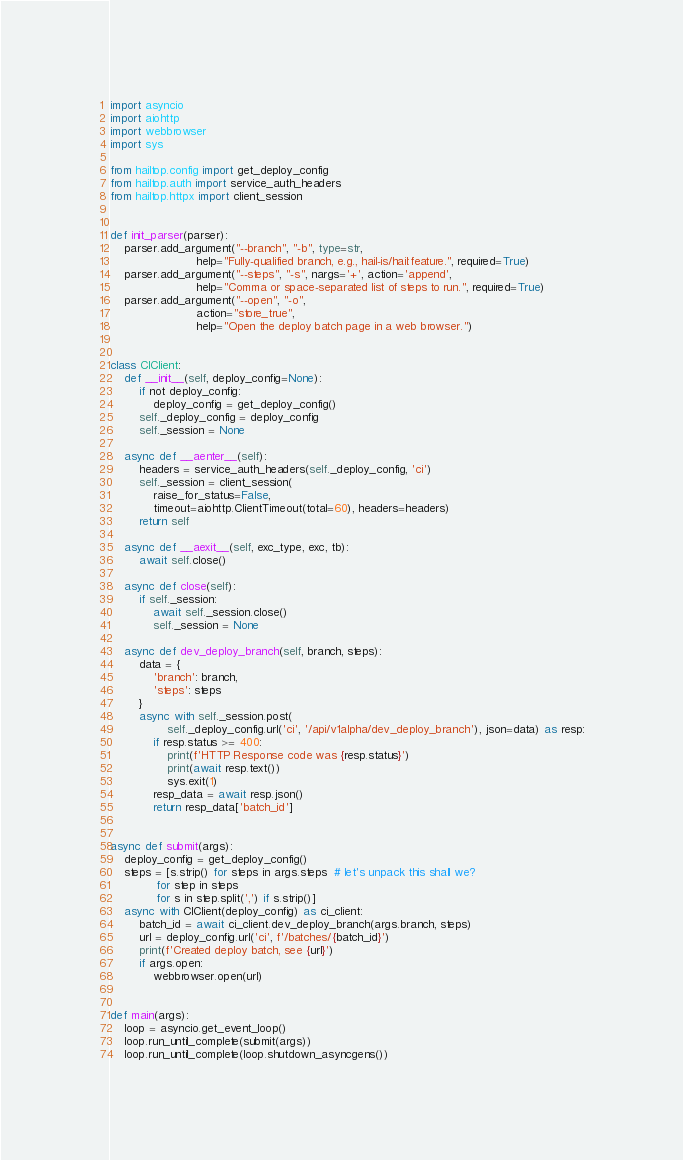<code> <loc_0><loc_0><loc_500><loc_500><_Python_>import asyncio
import aiohttp
import webbrowser
import sys

from hailtop.config import get_deploy_config
from hailtop.auth import service_auth_headers
from hailtop.httpx import client_session


def init_parser(parser):
    parser.add_argument("--branch", "-b", type=str,
                        help="Fully-qualified branch, e.g., hail-is/hail:feature.", required=True)
    parser.add_argument("--steps", "-s", nargs='+', action='append',
                        help="Comma or space-separated list of steps to run.", required=True)
    parser.add_argument("--open", "-o",
                        action="store_true",
                        help="Open the deploy batch page in a web browser.")


class CIClient:
    def __init__(self, deploy_config=None):
        if not deploy_config:
            deploy_config = get_deploy_config()
        self._deploy_config = deploy_config
        self._session = None

    async def __aenter__(self):
        headers = service_auth_headers(self._deploy_config, 'ci')
        self._session = client_session(
            raise_for_status=False,
            timeout=aiohttp.ClientTimeout(total=60), headers=headers)
        return self

    async def __aexit__(self, exc_type, exc, tb):
        await self.close()

    async def close(self):
        if self._session:
            await self._session.close()
            self._session = None

    async def dev_deploy_branch(self, branch, steps):
        data = {
            'branch': branch,
            'steps': steps
        }
        async with self._session.post(
                self._deploy_config.url('ci', '/api/v1alpha/dev_deploy_branch'), json=data) as resp:
            if resp.status >= 400:
                print(f'HTTP Response code was {resp.status}')
                print(await resp.text())
                sys.exit(1)
            resp_data = await resp.json()
            return resp_data['batch_id']


async def submit(args):
    deploy_config = get_deploy_config()
    steps = [s.strip() for steps in args.steps  # let's unpack this shall we?
             for step in steps
             for s in step.split(',') if s.strip()]
    async with CIClient(deploy_config) as ci_client:
        batch_id = await ci_client.dev_deploy_branch(args.branch, steps)
        url = deploy_config.url('ci', f'/batches/{batch_id}')
        print(f'Created deploy batch, see {url}')
        if args.open:
            webbrowser.open(url)


def main(args):
    loop = asyncio.get_event_loop()
    loop.run_until_complete(submit(args))
    loop.run_until_complete(loop.shutdown_asyncgens())
</code> 